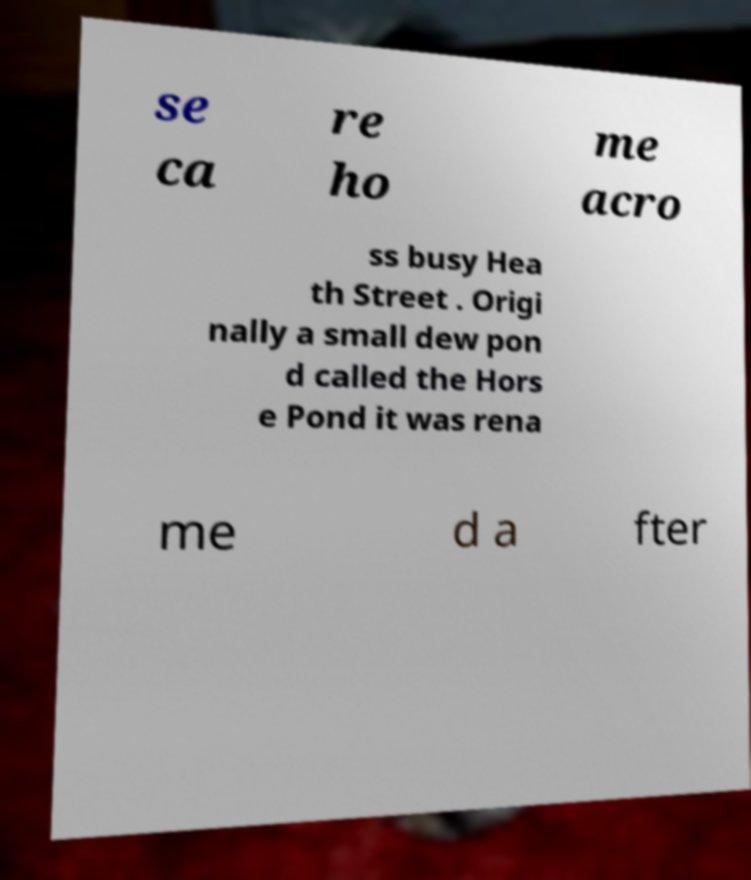Can you accurately transcribe the text from the provided image for me? se ca re ho me acro ss busy Hea th Street . Origi nally a small dew pon d called the Hors e Pond it was rena me d a fter 